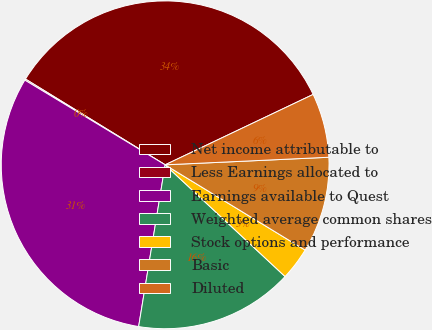Convert chart. <chart><loc_0><loc_0><loc_500><loc_500><pie_chart><fcel>Net income attributable to<fcel>Less Earnings allocated to<fcel>Earnings available to Quest<fcel>Weighted average common shares<fcel>Stock options and performance<fcel>Basic<fcel>Diluted<nl><fcel>34.17%<fcel>0.12%<fcel>31.06%<fcel>15.65%<fcel>3.23%<fcel>9.44%<fcel>6.33%<nl></chart> 